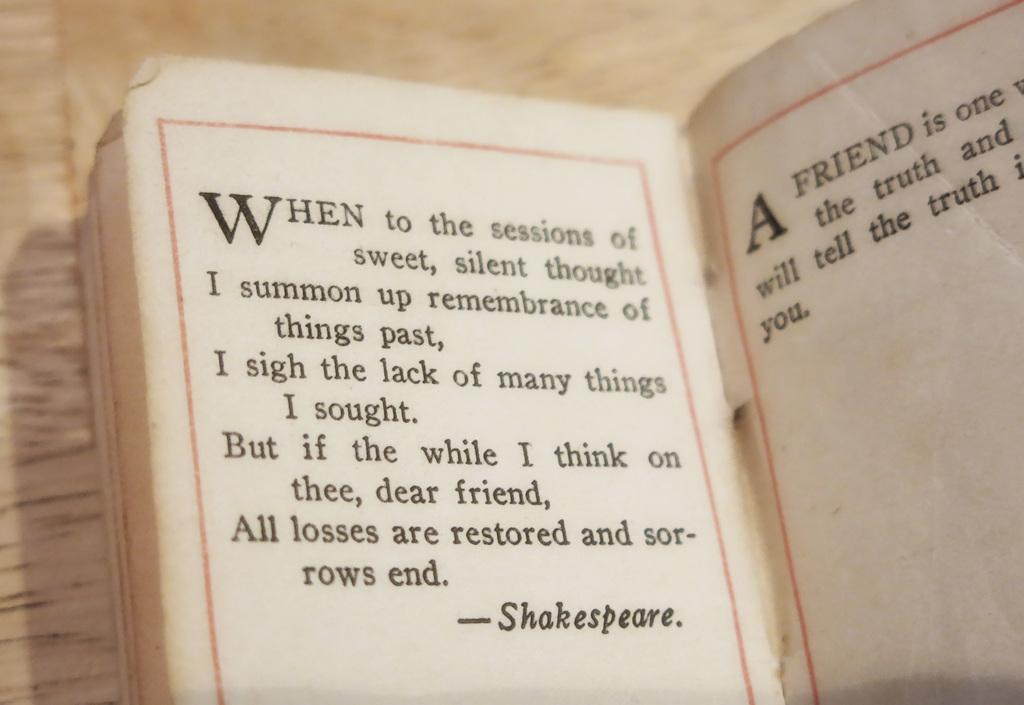<image>
Offer a succinct explanation of the picture presented. A book open to a quote about friendship by Shakespeare. 